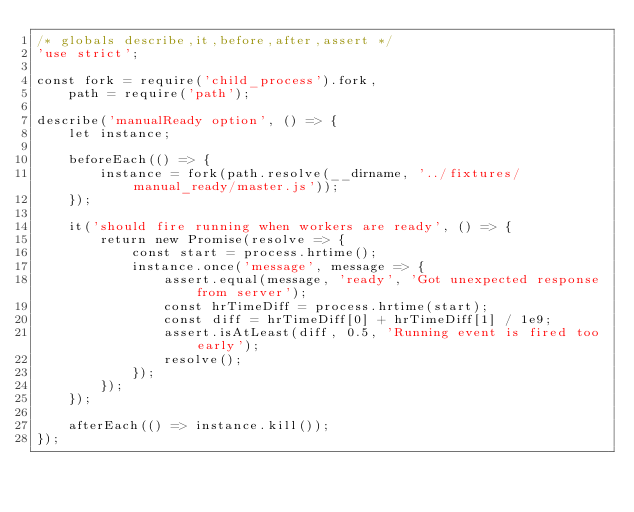Convert code to text. <code><loc_0><loc_0><loc_500><loc_500><_JavaScript_>/* globals describe,it,before,after,assert */
'use strict';

const fork = require('child_process').fork,
    path = require('path');

describe('manualReady option', () => {
    let instance;

    beforeEach(() => {
        instance = fork(path.resolve(__dirname, '../fixtures/manual_ready/master.js'));
    });

    it('should fire running when workers are ready', () => {
        return new Promise(resolve => {
            const start = process.hrtime();
            instance.once('message', message => {
                assert.equal(message, 'ready', 'Got unexpected response from server');
                const hrTimeDiff = process.hrtime(start);
                const diff = hrTimeDiff[0] + hrTimeDiff[1] / 1e9;
                assert.isAtLeast(diff, 0.5, 'Running event is fired too early');
                resolve();
            });
        });
    });

    afterEach(() => instance.kill());
});
</code> 